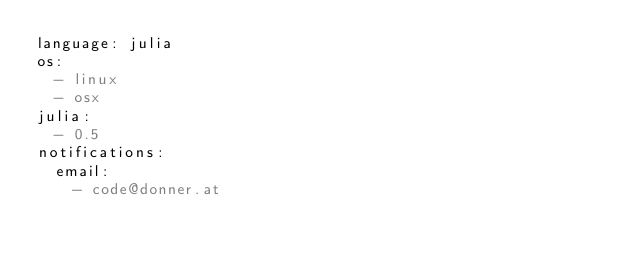<code> <loc_0><loc_0><loc_500><loc_500><_YAML_>language: julia
os:
  - linux
  - osx
julia:
  - 0.5
notifications:
  email:
    - code@donner.at
</code> 